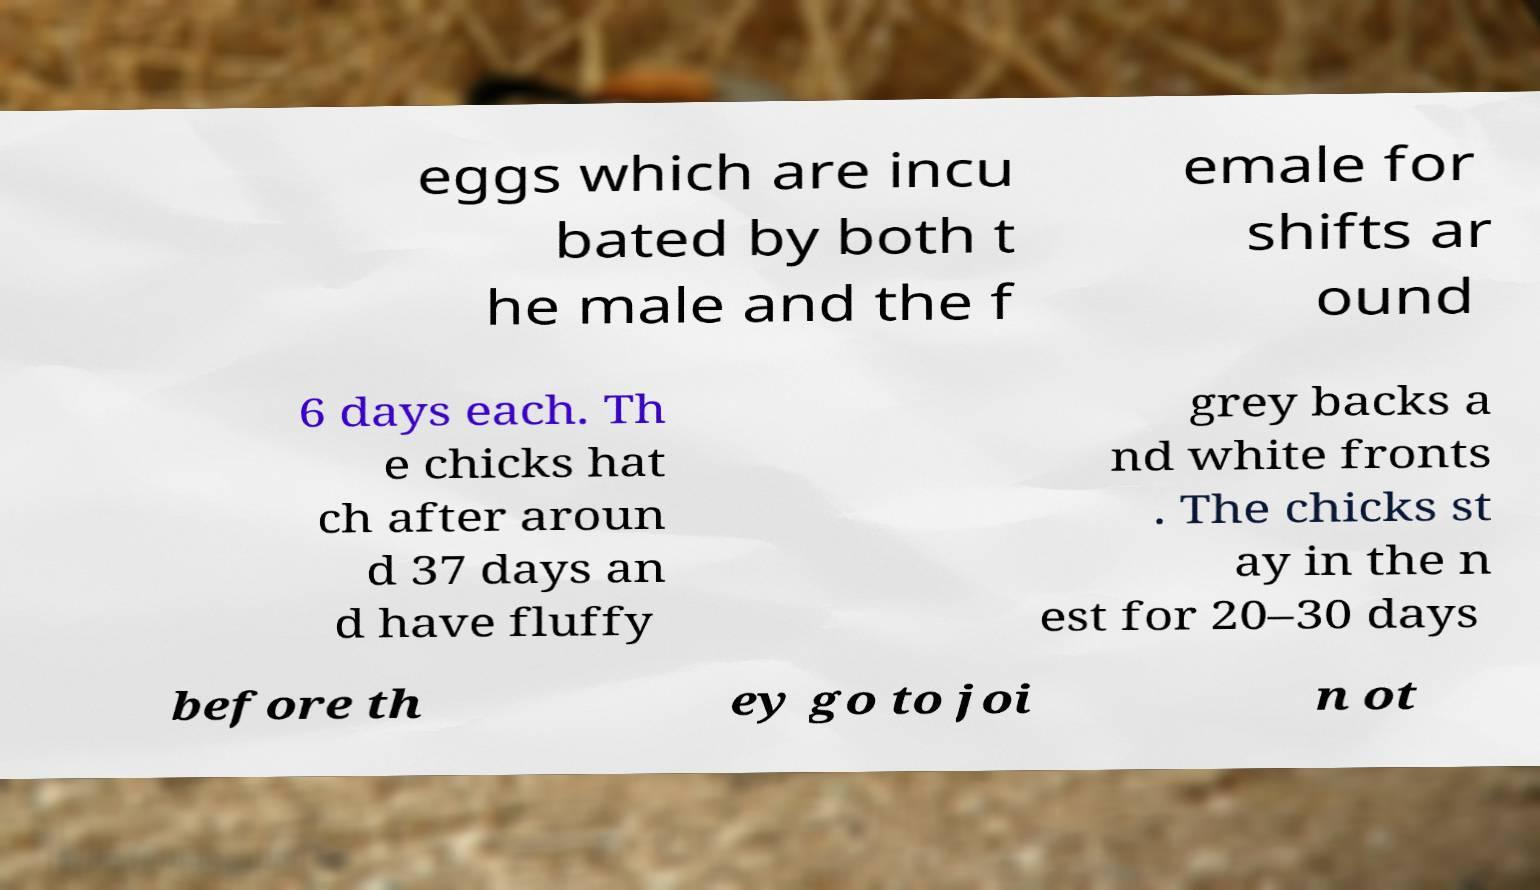Could you extract and type out the text from this image? eggs which are incu bated by both t he male and the f emale for shifts ar ound 6 days each. Th e chicks hat ch after aroun d 37 days an d have fluffy grey backs a nd white fronts . The chicks st ay in the n est for 20–30 days before th ey go to joi n ot 